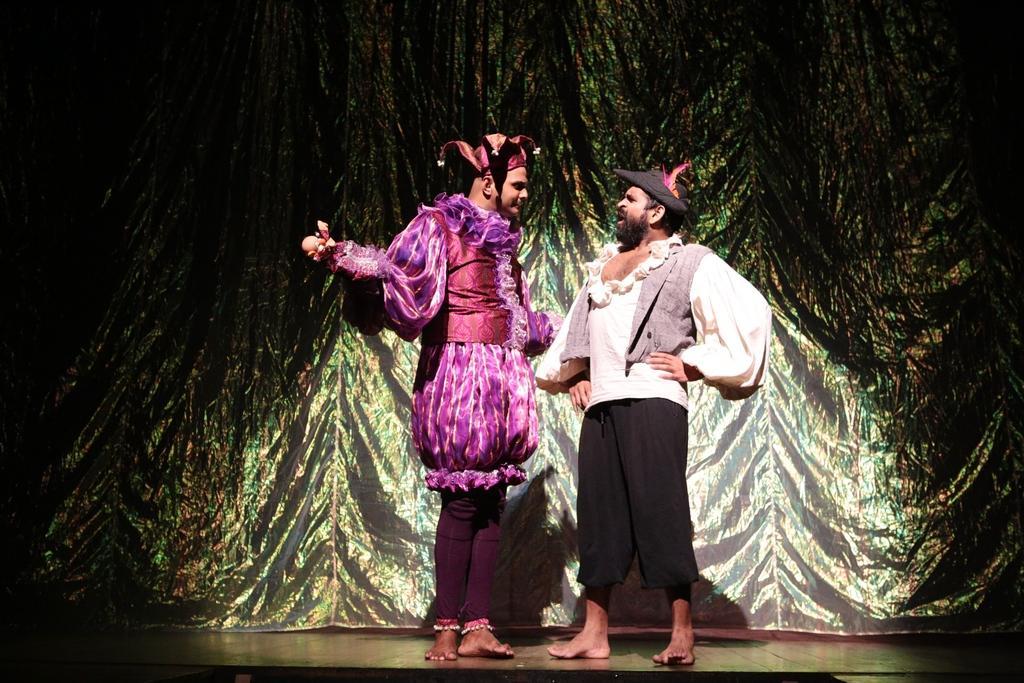Describe this image in one or two sentences. In this image, we can see two persons standing, in the background, we can see a curtain, we can see the spotlight on the person's. 